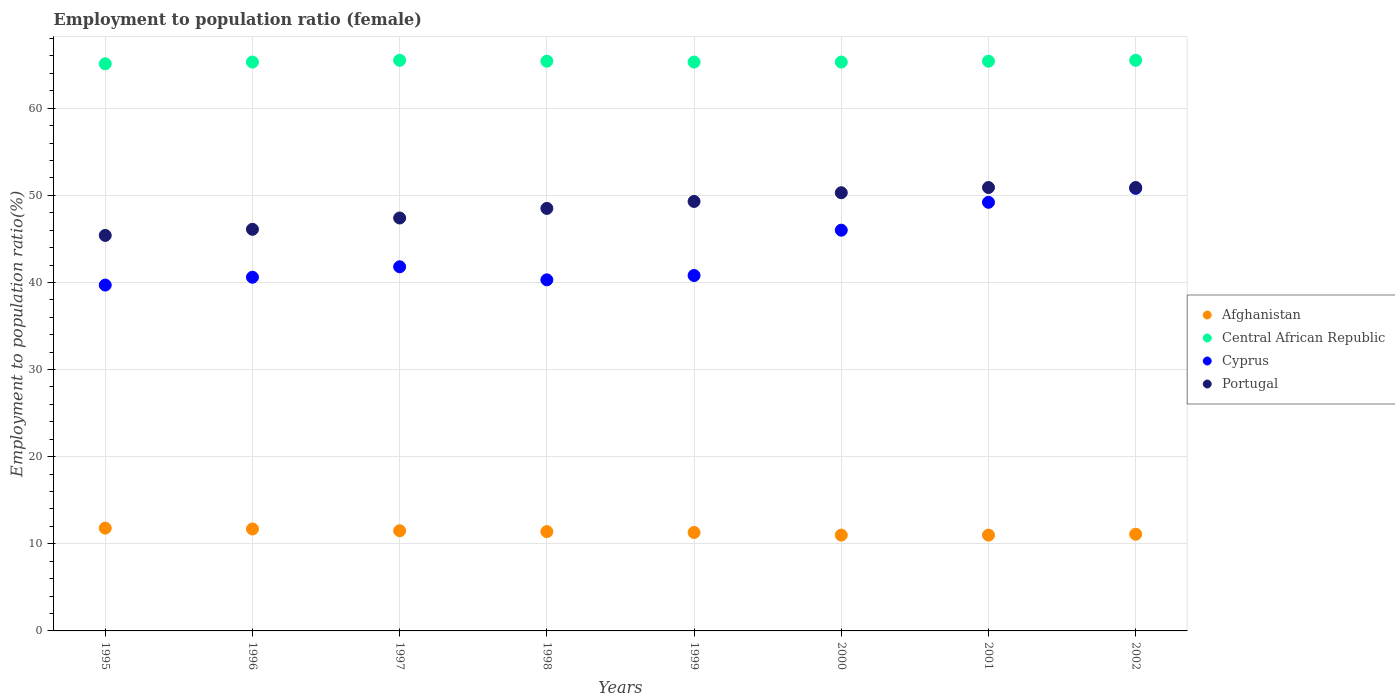Is the number of dotlines equal to the number of legend labels?
Make the answer very short. Yes. What is the employment to population ratio in Afghanistan in 1999?
Your answer should be compact. 11.3. Across all years, what is the maximum employment to population ratio in Cyprus?
Your answer should be very brief. 50.8. In which year was the employment to population ratio in Central African Republic maximum?
Offer a very short reply. 1997. In which year was the employment to population ratio in Cyprus minimum?
Ensure brevity in your answer.  1995. What is the total employment to population ratio in Portugal in the graph?
Ensure brevity in your answer.  388.8. What is the difference between the employment to population ratio in Afghanistan in 1997 and that in 2002?
Ensure brevity in your answer.  0.4. What is the difference between the employment to population ratio in Afghanistan in 1995 and the employment to population ratio in Portugal in 2001?
Ensure brevity in your answer.  -39.1. What is the average employment to population ratio in Portugal per year?
Your response must be concise. 48.6. In the year 1999, what is the difference between the employment to population ratio in Cyprus and employment to population ratio in Portugal?
Provide a succinct answer. -8.5. In how many years, is the employment to population ratio in Cyprus greater than 22 %?
Your answer should be very brief. 8. What is the ratio of the employment to population ratio in Portugal in 1998 to that in 2001?
Offer a very short reply. 0.95. Is the employment to population ratio in Portugal in 1998 less than that in 2001?
Your answer should be compact. Yes. What is the difference between the highest and the second highest employment to population ratio in Cyprus?
Ensure brevity in your answer.  1.6. What is the difference between the highest and the lowest employment to population ratio in Portugal?
Offer a terse response. 5.5. In how many years, is the employment to population ratio in Portugal greater than the average employment to population ratio in Portugal taken over all years?
Make the answer very short. 4. Is it the case that in every year, the sum of the employment to population ratio in Portugal and employment to population ratio in Afghanistan  is greater than the employment to population ratio in Central African Republic?
Make the answer very short. No. Is the employment to population ratio in Afghanistan strictly less than the employment to population ratio in Central African Republic over the years?
Make the answer very short. Yes. How many years are there in the graph?
Your answer should be very brief. 8. Are the values on the major ticks of Y-axis written in scientific E-notation?
Keep it short and to the point. No. How are the legend labels stacked?
Ensure brevity in your answer.  Vertical. What is the title of the graph?
Your answer should be very brief. Employment to population ratio (female). Does "St. Lucia" appear as one of the legend labels in the graph?
Offer a very short reply. No. What is the Employment to population ratio(%) of Afghanistan in 1995?
Keep it short and to the point. 11.8. What is the Employment to population ratio(%) in Central African Republic in 1995?
Give a very brief answer. 65.1. What is the Employment to population ratio(%) in Cyprus in 1995?
Give a very brief answer. 39.7. What is the Employment to population ratio(%) in Portugal in 1995?
Offer a terse response. 45.4. What is the Employment to population ratio(%) of Afghanistan in 1996?
Make the answer very short. 11.7. What is the Employment to population ratio(%) in Central African Republic in 1996?
Keep it short and to the point. 65.3. What is the Employment to population ratio(%) of Cyprus in 1996?
Your answer should be compact. 40.6. What is the Employment to population ratio(%) in Portugal in 1996?
Offer a very short reply. 46.1. What is the Employment to population ratio(%) in Afghanistan in 1997?
Your response must be concise. 11.5. What is the Employment to population ratio(%) in Central African Republic in 1997?
Your response must be concise. 65.5. What is the Employment to population ratio(%) in Cyprus in 1997?
Provide a short and direct response. 41.8. What is the Employment to population ratio(%) in Portugal in 1997?
Offer a very short reply. 47.4. What is the Employment to population ratio(%) in Afghanistan in 1998?
Your answer should be very brief. 11.4. What is the Employment to population ratio(%) of Central African Republic in 1998?
Your answer should be compact. 65.4. What is the Employment to population ratio(%) in Cyprus in 1998?
Offer a terse response. 40.3. What is the Employment to population ratio(%) of Portugal in 1998?
Provide a succinct answer. 48.5. What is the Employment to population ratio(%) of Afghanistan in 1999?
Keep it short and to the point. 11.3. What is the Employment to population ratio(%) of Central African Republic in 1999?
Your answer should be very brief. 65.3. What is the Employment to population ratio(%) of Cyprus in 1999?
Offer a terse response. 40.8. What is the Employment to population ratio(%) in Portugal in 1999?
Your response must be concise. 49.3. What is the Employment to population ratio(%) of Afghanistan in 2000?
Provide a succinct answer. 11. What is the Employment to population ratio(%) in Central African Republic in 2000?
Keep it short and to the point. 65.3. What is the Employment to population ratio(%) of Portugal in 2000?
Your response must be concise. 50.3. What is the Employment to population ratio(%) of Central African Republic in 2001?
Your answer should be compact. 65.4. What is the Employment to population ratio(%) in Cyprus in 2001?
Provide a short and direct response. 49.2. What is the Employment to population ratio(%) of Portugal in 2001?
Your answer should be compact. 50.9. What is the Employment to population ratio(%) of Afghanistan in 2002?
Provide a short and direct response. 11.1. What is the Employment to population ratio(%) of Central African Republic in 2002?
Your response must be concise. 65.5. What is the Employment to population ratio(%) of Cyprus in 2002?
Your answer should be very brief. 50.8. What is the Employment to population ratio(%) in Portugal in 2002?
Ensure brevity in your answer.  50.9. Across all years, what is the maximum Employment to population ratio(%) in Afghanistan?
Provide a short and direct response. 11.8. Across all years, what is the maximum Employment to population ratio(%) of Central African Republic?
Offer a very short reply. 65.5. Across all years, what is the maximum Employment to population ratio(%) in Cyprus?
Offer a very short reply. 50.8. Across all years, what is the maximum Employment to population ratio(%) of Portugal?
Your answer should be compact. 50.9. Across all years, what is the minimum Employment to population ratio(%) in Central African Republic?
Keep it short and to the point. 65.1. Across all years, what is the minimum Employment to population ratio(%) of Cyprus?
Give a very brief answer. 39.7. Across all years, what is the minimum Employment to population ratio(%) in Portugal?
Your answer should be compact. 45.4. What is the total Employment to population ratio(%) in Afghanistan in the graph?
Offer a terse response. 90.8. What is the total Employment to population ratio(%) in Central African Republic in the graph?
Ensure brevity in your answer.  522.8. What is the total Employment to population ratio(%) of Cyprus in the graph?
Your response must be concise. 349.2. What is the total Employment to population ratio(%) of Portugal in the graph?
Provide a short and direct response. 388.8. What is the difference between the Employment to population ratio(%) in Cyprus in 1995 and that in 1996?
Provide a short and direct response. -0.9. What is the difference between the Employment to population ratio(%) in Afghanistan in 1995 and that in 1997?
Provide a short and direct response. 0.3. What is the difference between the Employment to population ratio(%) of Cyprus in 1995 and that in 1997?
Offer a terse response. -2.1. What is the difference between the Employment to population ratio(%) of Afghanistan in 1995 and that in 1998?
Provide a succinct answer. 0.4. What is the difference between the Employment to population ratio(%) of Cyprus in 1995 and that in 1998?
Provide a succinct answer. -0.6. What is the difference between the Employment to population ratio(%) in Portugal in 1995 and that in 1998?
Offer a terse response. -3.1. What is the difference between the Employment to population ratio(%) in Cyprus in 1995 and that in 1999?
Keep it short and to the point. -1.1. What is the difference between the Employment to population ratio(%) in Cyprus in 1995 and that in 2000?
Make the answer very short. -6.3. What is the difference between the Employment to population ratio(%) of Portugal in 1995 and that in 2000?
Provide a short and direct response. -4.9. What is the difference between the Employment to population ratio(%) in Afghanistan in 1995 and that in 2001?
Provide a succinct answer. 0.8. What is the difference between the Employment to population ratio(%) of Portugal in 1995 and that in 2001?
Ensure brevity in your answer.  -5.5. What is the difference between the Employment to population ratio(%) in Afghanistan in 1995 and that in 2002?
Your answer should be very brief. 0.7. What is the difference between the Employment to population ratio(%) of Central African Republic in 1995 and that in 2002?
Ensure brevity in your answer.  -0.4. What is the difference between the Employment to population ratio(%) of Afghanistan in 1996 and that in 1998?
Offer a very short reply. 0.3. What is the difference between the Employment to population ratio(%) in Central African Republic in 1996 and that in 1998?
Ensure brevity in your answer.  -0.1. What is the difference between the Employment to population ratio(%) of Portugal in 1996 and that in 1998?
Give a very brief answer. -2.4. What is the difference between the Employment to population ratio(%) of Central African Republic in 1996 and that in 1999?
Make the answer very short. 0. What is the difference between the Employment to population ratio(%) in Afghanistan in 1996 and that in 2001?
Offer a very short reply. 0.7. What is the difference between the Employment to population ratio(%) of Cyprus in 1996 and that in 2001?
Offer a terse response. -8.6. What is the difference between the Employment to population ratio(%) of Portugal in 1996 and that in 2002?
Your answer should be very brief. -4.8. What is the difference between the Employment to population ratio(%) in Afghanistan in 1997 and that in 1998?
Your answer should be compact. 0.1. What is the difference between the Employment to population ratio(%) in Cyprus in 1997 and that in 1998?
Your response must be concise. 1.5. What is the difference between the Employment to population ratio(%) of Portugal in 1997 and that in 1998?
Your response must be concise. -1.1. What is the difference between the Employment to population ratio(%) of Afghanistan in 1997 and that in 1999?
Your answer should be compact. 0.2. What is the difference between the Employment to population ratio(%) in Afghanistan in 1997 and that in 2000?
Your response must be concise. 0.5. What is the difference between the Employment to population ratio(%) of Central African Republic in 1997 and that in 2000?
Offer a very short reply. 0.2. What is the difference between the Employment to population ratio(%) of Cyprus in 1997 and that in 2000?
Keep it short and to the point. -4.2. What is the difference between the Employment to population ratio(%) in Portugal in 1997 and that in 2001?
Make the answer very short. -3.5. What is the difference between the Employment to population ratio(%) of Cyprus in 1997 and that in 2002?
Your answer should be compact. -9. What is the difference between the Employment to population ratio(%) in Central African Republic in 1998 and that in 1999?
Offer a very short reply. 0.1. What is the difference between the Employment to population ratio(%) in Cyprus in 1998 and that in 1999?
Your answer should be very brief. -0.5. What is the difference between the Employment to population ratio(%) of Portugal in 1998 and that in 1999?
Ensure brevity in your answer.  -0.8. What is the difference between the Employment to population ratio(%) in Afghanistan in 1998 and that in 2000?
Make the answer very short. 0.4. What is the difference between the Employment to population ratio(%) in Central African Republic in 1998 and that in 2000?
Your answer should be compact. 0.1. What is the difference between the Employment to population ratio(%) in Portugal in 1998 and that in 2000?
Keep it short and to the point. -1.8. What is the difference between the Employment to population ratio(%) of Afghanistan in 1998 and that in 2001?
Provide a short and direct response. 0.4. What is the difference between the Employment to population ratio(%) of Central African Republic in 1998 and that in 2001?
Your answer should be very brief. 0. What is the difference between the Employment to population ratio(%) in Cyprus in 1998 and that in 2001?
Provide a short and direct response. -8.9. What is the difference between the Employment to population ratio(%) in Portugal in 1998 and that in 2001?
Offer a terse response. -2.4. What is the difference between the Employment to population ratio(%) in Afghanistan in 1998 and that in 2002?
Provide a short and direct response. 0.3. What is the difference between the Employment to population ratio(%) of Central African Republic in 1998 and that in 2002?
Provide a succinct answer. -0.1. What is the difference between the Employment to population ratio(%) in Cyprus in 1999 and that in 2000?
Keep it short and to the point. -5.2. What is the difference between the Employment to population ratio(%) of Portugal in 1999 and that in 2000?
Ensure brevity in your answer.  -1. What is the difference between the Employment to population ratio(%) of Cyprus in 1999 and that in 2001?
Your answer should be compact. -8.4. What is the difference between the Employment to population ratio(%) in Portugal in 1999 and that in 2001?
Provide a succinct answer. -1.6. What is the difference between the Employment to population ratio(%) of Central African Republic in 1999 and that in 2002?
Ensure brevity in your answer.  -0.2. What is the difference between the Employment to population ratio(%) of Cyprus in 1999 and that in 2002?
Your response must be concise. -10. What is the difference between the Employment to population ratio(%) in Central African Republic in 2000 and that in 2001?
Provide a succinct answer. -0.1. What is the difference between the Employment to population ratio(%) of Portugal in 2000 and that in 2001?
Provide a short and direct response. -0.6. What is the difference between the Employment to population ratio(%) in Afghanistan in 2001 and that in 2002?
Ensure brevity in your answer.  -0.1. What is the difference between the Employment to population ratio(%) of Portugal in 2001 and that in 2002?
Make the answer very short. 0. What is the difference between the Employment to population ratio(%) in Afghanistan in 1995 and the Employment to population ratio(%) in Central African Republic in 1996?
Offer a very short reply. -53.5. What is the difference between the Employment to population ratio(%) in Afghanistan in 1995 and the Employment to population ratio(%) in Cyprus in 1996?
Make the answer very short. -28.8. What is the difference between the Employment to population ratio(%) of Afghanistan in 1995 and the Employment to population ratio(%) of Portugal in 1996?
Offer a very short reply. -34.3. What is the difference between the Employment to population ratio(%) in Central African Republic in 1995 and the Employment to population ratio(%) in Portugal in 1996?
Provide a succinct answer. 19. What is the difference between the Employment to population ratio(%) of Afghanistan in 1995 and the Employment to population ratio(%) of Central African Republic in 1997?
Make the answer very short. -53.7. What is the difference between the Employment to population ratio(%) of Afghanistan in 1995 and the Employment to population ratio(%) of Portugal in 1997?
Keep it short and to the point. -35.6. What is the difference between the Employment to population ratio(%) in Central African Republic in 1995 and the Employment to population ratio(%) in Cyprus in 1997?
Offer a terse response. 23.3. What is the difference between the Employment to population ratio(%) of Central African Republic in 1995 and the Employment to population ratio(%) of Portugal in 1997?
Provide a succinct answer. 17.7. What is the difference between the Employment to population ratio(%) in Afghanistan in 1995 and the Employment to population ratio(%) in Central African Republic in 1998?
Offer a very short reply. -53.6. What is the difference between the Employment to population ratio(%) in Afghanistan in 1995 and the Employment to population ratio(%) in Cyprus in 1998?
Ensure brevity in your answer.  -28.5. What is the difference between the Employment to population ratio(%) of Afghanistan in 1995 and the Employment to population ratio(%) of Portugal in 1998?
Keep it short and to the point. -36.7. What is the difference between the Employment to population ratio(%) of Central African Republic in 1995 and the Employment to population ratio(%) of Cyprus in 1998?
Your answer should be compact. 24.8. What is the difference between the Employment to population ratio(%) of Central African Republic in 1995 and the Employment to population ratio(%) of Portugal in 1998?
Your answer should be very brief. 16.6. What is the difference between the Employment to population ratio(%) of Afghanistan in 1995 and the Employment to population ratio(%) of Central African Republic in 1999?
Your answer should be very brief. -53.5. What is the difference between the Employment to population ratio(%) of Afghanistan in 1995 and the Employment to population ratio(%) of Cyprus in 1999?
Provide a short and direct response. -29. What is the difference between the Employment to population ratio(%) of Afghanistan in 1995 and the Employment to population ratio(%) of Portugal in 1999?
Offer a terse response. -37.5. What is the difference between the Employment to population ratio(%) of Central African Republic in 1995 and the Employment to population ratio(%) of Cyprus in 1999?
Offer a terse response. 24.3. What is the difference between the Employment to population ratio(%) in Cyprus in 1995 and the Employment to population ratio(%) in Portugal in 1999?
Keep it short and to the point. -9.6. What is the difference between the Employment to population ratio(%) of Afghanistan in 1995 and the Employment to population ratio(%) of Central African Republic in 2000?
Provide a succinct answer. -53.5. What is the difference between the Employment to population ratio(%) of Afghanistan in 1995 and the Employment to population ratio(%) of Cyprus in 2000?
Make the answer very short. -34.2. What is the difference between the Employment to population ratio(%) in Afghanistan in 1995 and the Employment to population ratio(%) in Portugal in 2000?
Offer a very short reply. -38.5. What is the difference between the Employment to population ratio(%) in Cyprus in 1995 and the Employment to population ratio(%) in Portugal in 2000?
Offer a very short reply. -10.6. What is the difference between the Employment to population ratio(%) of Afghanistan in 1995 and the Employment to population ratio(%) of Central African Republic in 2001?
Provide a short and direct response. -53.6. What is the difference between the Employment to population ratio(%) of Afghanistan in 1995 and the Employment to population ratio(%) of Cyprus in 2001?
Offer a very short reply. -37.4. What is the difference between the Employment to population ratio(%) in Afghanistan in 1995 and the Employment to population ratio(%) in Portugal in 2001?
Your response must be concise. -39.1. What is the difference between the Employment to population ratio(%) in Afghanistan in 1995 and the Employment to population ratio(%) in Central African Republic in 2002?
Offer a terse response. -53.7. What is the difference between the Employment to population ratio(%) of Afghanistan in 1995 and the Employment to population ratio(%) of Cyprus in 2002?
Your answer should be very brief. -39. What is the difference between the Employment to population ratio(%) in Afghanistan in 1995 and the Employment to population ratio(%) in Portugal in 2002?
Keep it short and to the point. -39.1. What is the difference between the Employment to population ratio(%) in Central African Republic in 1995 and the Employment to population ratio(%) in Cyprus in 2002?
Your answer should be compact. 14.3. What is the difference between the Employment to population ratio(%) of Central African Republic in 1995 and the Employment to population ratio(%) of Portugal in 2002?
Provide a succinct answer. 14.2. What is the difference between the Employment to population ratio(%) in Cyprus in 1995 and the Employment to population ratio(%) in Portugal in 2002?
Give a very brief answer. -11.2. What is the difference between the Employment to population ratio(%) in Afghanistan in 1996 and the Employment to population ratio(%) in Central African Republic in 1997?
Make the answer very short. -53.8. What is the difference between the Employment to population ratio(%) of Afghanistan in 1996 and the Employment to population ratio(%) of Cyprus in 1997?
Your response must be concise. -30.1. What is the difference between the Employment to population ratio(%) of Afghanistan in 1996 and the Employment to population ratio(%) of Portugal in 1997?
Your answer should be compact. -35.7. What is the difference between the Employment to population ratio(%) in Central African Republic in 1996 and the Employment to population ratio(%) in Cyprus in 1997?
Keep it short and to the point. 23.5. What is the difference between the Employment to population ratio(%) of Cyprus in 1996 and the Employment to population ratio(%) of Portugal in 1997?
Offer a terse response. -6.8. What is the difference between the Employment to population ratio(%) in Afghanistan in 1996 and the Employment to population ratio(%) in Central African Republic in 1998?
Provide a short and direct response. -53.7. What is the difference between the Employment to population ratio(%) of Afghanistan in 1996 and the Employment to population ratio(%) of Cyprus in 1998?
Give a very brief answer. -28.6. What is the difference between the Employment to population ratio(%) of Afghanistan in 1996 and the Employment to population ratio(%) of Portugal in 1998?
Make the answer very short. -36.8. What is the difference between the Employment to population ratio(%) in Afghanistan in 1996 and the Employment to population ratio(%) in Central African Republic in 1999?
Give a very brief answer. -53.6. What is the difference between the Employment to population ratio(%) in Afghanistan in 1996 and the Employment to population ratio(%) in Cyprus in 1999?
Offer a very short reply. -29.1. What is the difference between the Employment to population ratio(%) of Afghanistan in 1996 and the Employment to population ratio(%) of Portugal in 1999?
Offer a terse response. -37.6. What is the difference between the Employment to population ratio(%) of Afghanistan in 1996 and the Employment to population ratio(%) of Central African Republic in 2000?
Make the answer very short. -53.6. What is the difference between the Employment to population ratio(%) of Afghanistan in 1996 and the Employment to population ratio(%) of Cyprus in 2000?
Keep it short and to the point. -34.3. What is the difference between the Employment to population ratio(%) in Afghanistan in 1996 and the Employment to population ratio(%) in Portugal in 2000?
Keep it short and to the point. -38.6. What is the difference between the Employment to population ratio(%) of Central African Republic in 1996 and the Employment to population ratio(%) of Cyprus in 2000?
Offer a very short reply. 19.3. What is the difference between the Employment to population ratio(%) in Central African Republic in 1996 and the Employment to population ratio(%) in Portugal in 2000?
Your response must be concise. 15. What is the difference between the Employment to population ratio(%) in Cyprus in 1996 and the Employment to population ratio(%) in Portugal in 2000?
Provide a short and direct response. -9.7. What is the difference between the Employment to population ratio(%) of Afghanistan in 1996 and the Employment to population ratio(%) of Central African Republic in 2001?
Ensure brevity in your answer.  -53.7. What is the difference between the Employment to population ratio(%) in Afghanistan in 1996 and the Employment to population ratio(%) in Cyprus in 2001?
Give a very brief answer. -37.5. What is the difference between the Employment to population ratio(%) of Afghanistan in 1996 and the Employment to population ratio(%) of Portugal in 2001?
Ensure brevity in your answer.  -39.2. What is the difference between the Employment to population ratio(%) in Cyprus in 1996 and the Employment to population ratio(%) in Portugal in 2001?
Offer a terse response. -10.3. What is the difference between the Employment to population ratio(%) of Afghanistan in 1996 and the Employment to population ratio(%) of Central African Republic in 2002?
Give a very brief answer. -53.8. What is the difference between the Employment to population ratio(%) of Afghanistan in 1996 and the Employment to population ratio(%) of Cyprus in 2002?
Ensure brevity in your answer.  -39.1. What is the difference between the Employment to population ratio(%) in Afghanistan in 1996 and the Employment to population ratio(%) in Portugal in 2002?
Make the answer very short. -39.2. What is the difference between the Employment to population ratio(%) in Cyprus in 1996 and the Employment to population ratio(%) in Portugal in 2002?
Ensure brevity in your answer.  -10.3. What is the difference between the Employment to population ratio(%) of Afghanistan in 1997 and the Employment to population ratio(%) of Central African Republic in 1998?
Ensure brevity in your answer.  -53.9. What is the difference between the Employment to population ratio(%) of Afghanistan in 1997 and the Employment to population ratio(%) of Cyprus in 1998?
Give a very brief answer. -28.8. What is the difference between the Employment to population ratio(%) of Afghanistan in 1997 and the Employment to population ratio(%) of Portugal in 1998?
Ensure brevity in your answer.  -37. What is the difference between the Employment to population ratio(%) of Central African Republic in 1997 and the Employment to population ratio(%) of Cyprus in 1998?
Offer a terse response. 25.2. What is the difference between the Employment to population ratio(%) in Cyprus in 1997 and the Employment to population ratio(%) in Portugal in 1998?
Your response must be concise. -6.7. What is the difference between the Employment to population ratio(%) in Afghanistan in 1997 and the Employment to population ratio(%) in Central African Republic in 1999?
Provide a short and direct response. -53.8. What is the difference between the Employment to population ratio(%) of Afghanistan in 1997 and the Employment to population ratio(%) of Cyprus in 1999?
Make the answer very short. -29.3. What is the difference between the Employment to population ratio(%) in Afghanistan in 1997 and the Employment to population ratio(%) in Portugal in 1999?
Your answer should be very brief. -37.8. What is the difference between the Employment to population ratio(%) in Central African Republic in 1997 and the Employment to population ratio(%) in Cyprus in 1999?
Provide a short and direct response. 24.7. What is the difference between the Employment to population ratio(%) of Cyprus in 1997 and the Employment to population ratio(%) of Portugal in 1999?
Offer a very short reply. -7.5. What is the difference between the Employment to population ratio(%) of Afghanistan in 1997 and the Employment to population ratio(%) of Central African Republic in 2000?
Provide a short and direct response. -53.8. What is the difference between the Employment to population ratio(%) of Afghanistan in 1997 and the Employment to population ratio(%) of Cyprus in 2000?
Your answer should be very brief. -34.5. What is the difference between the Employment to population ratio(%) of Afghanistan in 1997 and the Employment to population ratio(%) of Portugal in 2000?
Keep it short and to the point. -38.8. What is the difference between the Employment to population ratio(%) of Afghanistan in 1997 and the Employment to population ratio(%) of Central African Republic in 2001?
Your answer should be very brief. -53.9. What is the difference between the Employment to population ratio(%) in Afghanistan in 1997 and the Employment to population ratio(%) in Cyprus in 2001?
Offer a terse response. -37.7. What is the difference between the Employment to population ratio(%) in Afghanistan in 1997 and the Employment to population ratio(%) in Portugal in 2001?
Provide a short and direct response. -39.4. What is the difference between the Employment to population ratio(%) in Central African Republic in 1997 and the Employment to population ratio(%) in Portugal in 2001?
Offer a terse response. 14.6. What is the difference between the Employment to population ratio(%) of Cyprus in 1997 and the Employment to population ratio(%) of Portugal in 2001?
Make the answer very short. -9.1. What is the difference between the Employment to population ratio(%) in Afghanistan in 1997 and the Employment to population ratio(%) in Central African Republic in 2002?
Make the answer very short. -54. What is the difference between the Employment to population ratio(%) in Afghanistan in 1997 and the Employment to population ratio(%) in Cyprus in 2002?
Provide a succinct answer. -39.3. What is the difference between the Employment to population ratio(%) of Afghanistan in 1997 and the Employment to population ratio(%) of Portugal in 2002?
Your response must be concise. -39.4. What is the difference between the Employment to population ratio(%) of Central African Republic in 1997 and the Employment to population ratio(%) of Cyprus in 2002?
Your answer should be very brief. 14.7. What is the difference between the Employment to population ratio(%) in Central African Republic in 1997 and the Employment to population ratio(%) in Portugal in 2002?
Offer a very short reply. 14.6. What is the difference between the Employment to population ratio(%) of Afghanistan in 1998 and the Employment to population ratio(%) of Central African Republic in 1999?
Give a very brief answer. -53.9. What is the difference between the Employment to population ratio(%) in Afghanistan in 1998 and the Employment to population ratio(%) in Cyprus in 1999?
Give a very brief answer. -29.4. What is the difference between the Employment to population ratio(%) of Afghanistan in 1998 and the Employment to population ratio(%) of Portugal in 1999?
Provide a succinct answer. -37.9. What is the difference between the Employment to population ratio(%) of Central African Republic in 1998 and the Employment to population ratio(%) of Cyprus in 1999?
Give a very brief answer. 24.6. What is the difference between the Employment to population ratio(%) of Cyprus in 1998 and the Employment to population ratio(%) of Portugal in 1999?
Ensure brevity in your answer.  -9. What is the difference between the Employment to population ratio(%) in Afghanistan in 1998 and the Employment to population ratio(%) in Central African Republic in 2000?
Your answer should be compact. -53.9. What is the difference between the Employment to population ratio(%) in Afghanistan in 1998 and the Employment to population ratio(%) in Cyprus in 2000?
Your answer should be very brief. -34.6. What is the difference between the Employment to population ratio(%) in Afghanistan in 1998 and the Employment to population ratio(%) in Portugal in 2000?
Offer a terse response. -38.9. What is the difference between the Employment to population ratio(%) in Central African Republic in 1998 and the Employment to population ratio(%) in Cyprus in 2000?
Your answer should be very brief. 19.4. What is the difference between the Employment to population ratio(%) of Afghanistan in 1998 and the Employment to population ratio(%) of Central African Republic in 2001?
Offer a terse response. -54. What is the difference between the Employment to population ratio(%) in Afghanistan in 1998 and the Employment to population ratio(%) in Cyprus in 2001?
Your response must be concise. -37.8. What is the difference between the Employment to population ratio(%) in Afghanistan in 1998 and the Employment to population ratio(%) in Portugal in 2001?
Your answer should be compact. -39.5. What is the difference between the Employment to population ratio(%) in Central African Republic in 1998 and the Employment to population ratio(%) in Cyprus in 2001?
Offer a very short reply. 16.2. What is the difference between the Employment to population ratio(%) in Central African Republic in 1998 and the Employment to population ratio(%) in Portugal in 2001?
Your response must be concise. 14.5. What is the difference between the Employment to population ratio(%) in Cyprus in 1998 and the Employment to population ratio(%) in Portugal in 2001?
Offer a terse response. -10.6. What is the difference between the Employment to population ratio(%) of Afghanistan in 1998 and the Employment to population ratio(%) of Central African Republic in 2002?
Offer a terse response. -54.1. What is the difference between the Employment to population ratio(%) in Afghanistan in 1998 and the Employment to population ratio(%) in Cyprus in 2002?
Make the answer very short. -39.4. What is the difference between the Employment to population ratio(%) in Afghanistan in 1998 and the Employment to population ratio(%) in Portugal in 2002?
Your answer should be compact. -39.5. What is the difference between the Employment to population ratio(%) in Central African Republic in 1998 and the Employment to population ratio(%) in Cyprus in 2002?
Give a very brief answer. 14.6. What is the difference between the Employment to population ratio(%) of Cyprus in 1998 and the Employment to population ratio(%) of Portugal in 2002?
Provide a succinct answer. -10.6. What is the difference between the Employment to population ratio(%) of Afghanistan in 1999 and the Employment to population ratio(%) of Central African Republic in 2000?
Your response must be concise. -54. What is the difference between the Employment to population ratio(%) of Afghanistan in 1999 and the Employment to population ratio(%) of Cyprus in 2000?
Offer a very short reply. -34.7. What is the difference between the Employment to population ratio(%) in Afghanistan in 1999 and the Employment to population ratio(%) in Portugal in 2000?
Your response must be concise. -39. What is the difference between the Employment to population ratio(%) of Central African Republic in 1999 and the Employment to population ratio(%) of Cyprus in 2000?
Your answer should be very brief. 19.3. What is the difference between the Employment to population ratio(%) in Cyprus in 1999 and the Employment to population ratio(%) in Portugal in 2000?
Give a very brief answer. -9.5. What is the difference between the Employment to population ratio(%) in Afghanistan in 1999 and the Employment to population ratio(%) in Central African Republic in 2001?
Ensure brevity in your answer.  -54.1. What is the difference between the Employment to population ratio(%) of Afghanistan in 1999 and the Employment to population ratio(%) of Cyprus in 2001?
Offer a very short reply. -37.9. What is the difference between the Employment to population ratio(%) in Afghanistan in 1999 and the Employment to population ratio(%) in Portugal in 2001?
Give a very brief answer. -39.6. What is the difference between the Employment to population ratio(%) in Central African Republic in 1999 and the Employment to population ratio(%) in Cyprus in 2001?
Ensure brevity in your answer.  16.1. What is the difference between the Employment to population ratio(%) of Afghanistan in 1999 and the Employment to population ratio(%) of Central African Republic in 2002?
Keep it short and to the point. -54.2. What is the difference between the Employment to population ratio(%) in Afghanistan in 1999 and the Employment to population ratio(%) in Cyprus in 2002?
Offer a very short reply. -39.5. What is the difference between the Employment to population ratio(%) of Afghanistan in 1999 and the Employment to population ratio(%) of Portugal in 2002?
Offer a very short reply. -39.6. What is the difference between the Employment to population ratio(%) in Cyprus in 1999 and the Employment to population ratio(%) in Portugal in 2002?
Ensure brevity in your answer.  -10.1. What is the difference between the Employment to population ratio(%) in Afghanistan in 2000 and the Employment to population ratio(%) in Central African Republic in 2001?
Provide a succinct answer. -54.4. What is the difference between the Employment to population ratio(%) of Afghanistan in 2000 and the Employment to population ratio(%) of Cyprus in 2001?
Offer a very short reply. -38.2. What is the difference between the Employment to population ratio(%) in Afghanistan in 2000 and the Employment to population ratio(%) in Portugal in 2001?
Make the answer very short. -39.9. What is the difference between the Employment to population ratio(%) of Afghanistan in 2000 and the Employment to population ratio(%) of Central African Republic in 2002?
Your response must be concise. -54.5. What is the difference between the Employment to population ratio(%) in Afghanistan in 2000 and the Employment to population ratio(%) in Cyprus in 2002?
Give a very brief answer. -39.8. What is the difference between the Employment to population ratio(%) of Afghanistan in 2000 and the Employment to population ratio(%) of Portugal in 2002?
Give a very brief answer. -39.9. What is the difference between the Employment to population ratio(%) of Afghanistan in 2001 and the Employment to population ratio(%) of Central African Republic in 2002?
Keep it short and to the point. -54.5. What is the difference between the Employment to population ratio(%) in Afghanistan in 2001 and the Employment to population ratio(%) in Cyprus in 2002?
Offer a terse response. -39.8. What is the difference between the Employment to population ratio(%) of Afghanistan in 2001 and the Employment to population ratio(%) of Portugal in 2002?
Keep it short and to the point. -39.9. What is the average Employment to population ratio(%) in Afghanistan per year?
Provide a succinct answer. 11.35. What is the average Employment to population ratio(%) of Central African Republic per year?
Your answer should be compact. 65.35. What is the average Employment to population ratio(%) of Cyprus per year?
Provide a short and direct response. 43.65. What is the average Employment to population ratio(%) of Portugal per year?
Keep it short and to the point. 48.6. In the year 1995, what is the difference between the Employment to population ratio(%) of Afghanistan and Employment to population ratio(%) of Central African Republic?
Your response must be concise. -53.3. In the year 1995, what is the difference between the Employment to population ratio(%) in Afghanistan and Employment to population ratio(%) in Cyprus?
Your answer should be compact. -27.9. In the year 1995, what is the difference between the Employment to population ratio(%) of Afghanistan and Employment to population ratio(%) of Portugal?
Your answer should be compact. -33.6. In the year 1995, what is the difference between the Employment to population ratio(%) of Central African Republic and Employment to population ratio(%) of Cyprus?
Provide a succinct answer. 25.4. In the year 1995, what is the difference between the Employment to population ratio(%) in Central African Republic and Employment to population ratio(%) in Portugal?
Give a very brief answer. 19.7. In the year 1996, what is the difference between the Employment to population ratio(%) of Afghanistan and Employment to population ratio(%) of Central African Republic?
Provide a succinct answer. -53.6. In the year 1996, what is the difference between the Employment to population ratio(%) of Afghanistan and Employment to population ratio(%) of Cyprus?
Your response must be concise. -28.9. In the year 1996, what is the difference between the Employment to population ratio(%) of Afghanistan and Employment to population ratio(%) of Portugal?
Provide a succinct answer. -34.4. In the year 1996, what is the difference between the Employment to population ratio(%) in Central African Republic and Employment to population ratio(%) in Cyprus?
Make the answer very short. 24.7. In the year 1996, what is the difference between the Employment to population ratio(%) of Central African Republic and Employment to population ratio(%) of Portugal?
Give a very brief answer. 19.2. In the year 1997, what is the difference between the Employment to population ratio(%) of Afghanistan and Employment to population ratio(%) of Central African Republic?
Provide a succinct answer. -54. In the year 1997, what is the difference between the Employment to population ratio(%) in Afghanistan and Employment to population ratio(%) in Cyprus?
Offer a very short reply. -30.3. In the year 1997, what is the difference between the Employment to population ratio(%) in Afghanistan and Employment to population ratio(%) in Portugal?
Give a very brief answer. -35.9. In the year 1997, what is the difference between the Employment to population ratio(%) of Central African Republic and Employment to population ratio(%) of Cyprus?
Your answer should be compact. 23.7. In the year 1997, what is the difference between the Employment to population ratio(%) of Central African Republic and Employment to population ratio(%) of Portugal?
Ensure brevity in your answer.  18.1. In the year 1998, what is the difference between the Employment to population ratio(%) of Afghanistan and Employment to population ratio(%) of Central African Republic?
Your answer should be very brief. -54. In the year 1998, what is the difference between the Employment to population ratio(%) in Afghanistan and Employment to population ratio(%) in Cyprus?
Offer a very short reply. -28.9. In the year 1998, what is the difference between the Employment to population ratio(%) in Afghanistan and Employment to population ratio(%) in Portugal?
Ensure brevity in your answer.  -37.1. In the year 1998, what is the difference between the Employment to population ratio(%) of Central African Republic and Employment to population ratio(%) of Cyprus?
Your response must be concise. 25.1. In the year 1998, what is the difference between the Employment to population ratio(%) in Cyprus and Employment to population ratio(%) in Portugal?
Your answer should be compact. -8.2. In the year 1999, what is the difference between the Employment to population ratio(%) of Afghanistan and Employment to population ratio(%) of Central African Republic?
Your answer should be compact. -54. In the year 1999, what is the difference between the Employment to population ratio(%) of Afghanistan and Employment to population ratio(%) of Cyprus?
Your answer should be very brief. -29.5. In the year 1999, what is the difference between the Employment to population ratio(%) in Afghanistan and Employment to population ratio(%) in Portugal?
Offer a very short reply. -38. In the year 1999, what is the difference between the Employment to population ratio(%) of Cyprus and Employment to population ratio(%) of Portugal?
Provide a succinct answer. -8.5. In the year 2000, what is the difference between the Employment to population ratio(%) in Afghanistan and Employment to population ratio(%) in Central African Republic?
Offer a very short reply. -54.3. In the year 2000, what is the difference between the Employment to population ratio(%) of Afghanistan and Employment to population ratio(%) of Cyprus?
Ensure brevity in your answer.  -35. In the year 2000, what is the difference between the Employment to population ratio(%) in Afghanistan and Employment to population ratio(%) in Portugal?
Offer a terse response. -39.3. In the year 2000, what is the difference between the Employment to population ratio(%) of Central African Republic and Employment to population ratio(%) of Cyprus?
Provide a short and direct response. 19.3. In the year 2000, what is the difference between the Employment to population ratio(%) of Central African Republic and Employment to population ratio(%) of Portugal?
Your answer should be very brief. 15. In the year 2000, what is the difference between the Employment to population ratio(%) of Cyprus and Employment to population ratio(%) of Portugal?
Your response must be concise. -4.3. In the year 2001, what is the difference between the Employment to population ratio(%) in Afghanistan and Employment to population ratio(%) in Central African Republic?
Ensure brevity in your answer.  -54.4. In the year 2001, what is the difference between the Employment to population ratio(%) in Afghanistan and Employment to population ratio(%) in Cyprus?
Offer a very short reply. -38.2. In the year 2001, what is the difference between the Employment to population ratio(%) of Afghanistan and Employment to population ratio(%) of Portugal?
Keep it short and to the point. -39.9. In the year 2001, what is the difference between the Employment to population ratio(%) in Cyprus and Employment to population ratio(%) in Portugal?
Provide a short and direct response. -1.7. In the year 2002, what is the difference between the Employment to population ratio(%) of Afghanistan and Employment to population ratio(%) of Central African Republic?
Keep it short and to the point. -54.4. In the year 2002, what is the difference between the Employment to population ratio(%) in Afghanistan and Employment to population ratio(%) in Cyprus?
Your response must be concise. -39.7. In the year 2002, what is the difference between the Employment to population ratio(%) in Afghanistan and Employment to population ratio(%) in Portugal?
Provide a succinct answer. -39.8. What is the ratio of the Employment to population ratio(%) of Afghanistan in 1995 to that in 1996?
Make the answer very short. 1.01. What is the ratio of the Employment to population ratio(%) in Central African Republic in 1995 to that in 1996?
Your answer should be compact. 1. What is the ratio of the Employment to population ratio(%) in Cyprus in 1995 to that in 1996?
Give a very brief answer. 0.98. What is the ratio of the Employment to population ratio(%) of Portugal in 1995 to that in 1996?
Ensure brevity in your answer.  0.98. What is the ratio of the Employment to population ratio(%) in Afghanistan in 1995 to that in 1997?
Your response must be concise. 1.03. What is the ratio of the Employment to population ratio(%) in Cyprus in 1995 to that in 1997?
Ensure brevity in your answer.  0.95. What is the ratio of the Employment to population ratio(%) of Portugal in 1995 to that in 1997?
Ensure brevity in your answer.  0.96. What is the ratio of the Employment to population ratio(%) of Afghanistan in 1995 to that in 1998?
Give a very brief answer. 1.04. What is the ratio of the Employment to population ratio(%) of Central African Republic in 1995 to that in 1998?
Ensure brevity in your answer.  1. What is the ratio of the Employment to population ratio(%) of Cyprus in 1995 to that in 1998?
Ensure brevity in your answer.  0.99. What is the ratio of the Employment to population ratio(%) in Portugal in 1995 to that in 1998?
Your answer should be very brief. 0.94. What is the ratio of the Employment to population ratio(%) in Afghanistan in 1995 to that in 1999?
Your answer should be compact. 1.04. What is the ratio of the Employment to population ratio(%) in Central African Republic in 1995 to that in 1999?
Keep it short and to the point. 1. What is the ratio of the Employment to population ratio(%) in Cyprus in 1995 to that in 1999?
Your answer should be very brief. 0.97. What is the ratio of the Employment to population ratio(%) of Portugal in 1995 to that in 1999?
Provide a short and direct response. 0.92. What is the ratio of the Employment to population ratio(%) of Afghanistan in 1995 to that in 2000?
Ensure brevity in your answer.  1.07. What is the ratio of the Employment to population ratio(%) in Central African Republic in 1995 to that in 2000?
Make the answer very short. 1. What is the ratio of the Employment to population ratio(%) in Cyprus in 1995 to that in 2000?
Provide a short and direct response. 0.86. What is the ratio of the Employment to population ratio(%) of Portugal in 1995 to that in 2000?
Provide a short and direct response. 0.9. What is the ratio of the Employment to population ratio(%) of Afghanistan in 1995 to that in 2001?
Offer a very short reply. 1.07. What is the ratio of the Employment to population ratio(%) of Cyprus in 1995 to that in 2001?
Ensure brevity in your answer.  0.81. What is the ratio of the Employment to population ratio(%) of Portugal in 1995 to that in 2001?
Your answer should be compact. 0.89. What is the ratio of the Employment to population ratio(%) in Afghanistan in 1995 to that in 2002?
Ensure brevity in your answer.  1.06. What is the ratio of the Employment to population ratio(%) in Central African Republic in 1995 to that in 2002?
Keep it short and to the point. 0.99. What is the ratio of the Employment to population ratio(%) of Cyprus in 1995 to that in 2002?
Provide a short and direct response. 0.78. What is the ratio of the Employment to population ratio(%) in Portugal in 1995 to that in 2002?
Your answer should be very brief. 0.89. What is the ratio of the Employment to population ratio(%) in Afghanistan in 1996 to that in 1997?
Offer a terse response. 1.02. What is the ratio of the Employment to population ratio(%) in Central African Republic in 1996 to that in 1997?
Your answer should be very brief. 1. What is the ratio of the Employment to population ratio(%) in Cyprus in 1996 to that in 1997?
Keep it short and to the point. 0.97. What is the ratio of the Employment to population ratio(%) in Portugal in 1996 to that in 1997?
Provide a short and direct response. 0.97. What is the ratio of the Employment to population ratio(%) of Afghanistan in 1996 to that in 1998?
Your answer should be compact. 1.03. What is the ratio of the Employment to population ratio(%) of Central African Republic in 1996 to that in 1998?
Ensure brevity in your answer.  1. What is the ratio of the Employment to population ratio(%) of Cyprus in 1996 to that in 1998?
Offer a very short reply. 1.01. What is the ratio of the Employment to population ratio(%) of Portugal in 1996 to that in 1998?
Keep it short and to the point. 0.95. What is the ratio of the Employment to population ratio(%) in Afghanistan in 1996 to that in 1999?
Keep it short and to the point. 1.04. What is the ratio of the Employment to population ratio(%) of Central African Republic in 1996 to that in 1999?
Your response must be concise. 1. What is the ratio of the Employment to population ratio(%) of Cyprus in 1996 to that in 1999?
Make the answer very short. 1. What is the ratio of the Employment to population ratio(%) in Portugal in 1996 to that in 1999?
Provide a succinct answer. 0.94. What is the ratio of the Employment to population ratio(%) in Afghanistan in 1996 to that in 2000?
Your answer should be compact. 1.06. What is the ratio of the Employment to population ratio(%) in Cyprus in 1996 to that in 2000?
Your answer should be very brief. 0.88. What is the ratio of the Employment to population ratio(%) of Portugal in 1996 to that in 2000?
Offer a very short reply. 0.92. What is the ratio of the Employment to population ratio(%) in Afghanistan in 1996 to that in 2001?
Offer a terse response. 1.06. What is the ratio of the Employment to population ratio(%) of Cyprus in 1996 to that in 2001?
Keep it short and to the point. 0.83. What is the ratio of the Employment to population ratio(%) of Portugal in 1996 to that in 2001?
Your answer should be compact. 0.91. What is the ratio of the Employment to population ratio(%) of Afghanistan in 1996 to that in 2002?
Provide a succinct answer. 1.05. What is the ratio of the Employment to population ratio(%) of Cyprus in 1996 to that in 2002?
Offer a terse response. 0.8. What is the ratio of the Employment to population ratio(%) of Portugal in 1996 to that in 2002?
Provide a short and direct response. 0.91. What is the ratio of the Employment to population ratio(%) in Afghanistan in 1997 to that in 1998?
Provide a succinct answer. 1.01. What is the ratio of the Employment to population ratio(%) of Central African Republic in 1997 to that in 1998?
Offer a very short reply. 1. What is the ratio of the Employment to population ratio(%) of Cyprus in 1997 to that in 1998?
Keep it short and to the point. 1.04. What is the ratio of the Employment to population ratio(%) of Portugal in 1997 to that in 1998?
Your answer should be compact. 0.98. What is the ratio of the Employment to population ratio(%) of Afghanistan in 1997 to that in 1999?
Give a very brief answer. 1.02. What is the ratio of the Employment to population ratio(%) in Central African Republic in 1997 to that in 1999?
Provide a short and direct response. 1. What is the ratio of the Employment to population ratio(%) in Cyprus in 1997 to that in 1999?
Your response must be concise. 1.02. What is the ratio of the Employment to population ratio(%) in Portugal in 1997 to that in 1999?
Ensure brevity in your answer.  0.96. What is the ratio of the Employment to population ratio(%) in Afghanistan in 1997 to that in 2000?
Provide a short and direct response. 1.05. What is the ratio of the Employment to population ratio(%) of Cyprus in 1997 to that in 2000?
Offer a very short reply. 0.91. What is the ratio of the Employment to population ratio(%) of Portugal in 1997 to that in 2000?
Provide a succinct answer. 0.94. What is the ratio of the Employment to population ratio(%) of Afghanistan in 1997 to that in 2001?
Your response must be concise. 1.05. What is the ratio of the Employment to population ratio(%) in Central African Republic in 1997 to that in 2001?
Offer a terse response. 1. What is the ratio of the Employment to population ratio(%) in Cyprus in 1997 to that in 2001?
Your response must be concise. 0.85. What is the ratio of the Employment to population ratio(%) of Portugal in 1997 to that in 2001?
Give a very brief answer. 0.93. What is the ratio of the Employment to population ratio(%) in Afghanistan in 1997 to that in 2002?
Your answer should be compact. 1.04. What is the ratio of the Employment to population ratio(%) of Central African Republic in 1997 to that in 2002?
Make the answer very short. 1. What is the ratio of the Employment to population ratio(%) of Cyprus in 1997 to that in 2002?
Your answer should be compact. 0.82. What is the ratio of the Employment to population ratio(%) of Portugal in 1997 to that in 2002?
Give a very brief answer. 0.93. What is the ratio of the Employment to population ratio(%) in Afghanistan in 1998 to that in 1999?
Offer a terse response. 1.01. What is the ratio of the Employment to population ratio(%) of Cyprus in 1998 to that in 1999?
Provide a short and direct response. 0.99. What is the ratio of the Employment to population ratio(%) in Portugal in 1998 to that in 1999?
Your response must be concise. 0.98. What is the ratio of the Employment to population ratio(%) in Afghanistan in 1998 to that in 2000?
Provide a short and direct response. 1.04. What is the ratio of the Employment to population ratio(%) of Central African Republic in 1998 to that in 2000?
Your response must be concise. 1. What is the ratio of the Employment to population ratio(%) in Cyprus in 1998 to that in 2000?
Provide a short and direct response. 0.88. What is the ratio of the Employment to population ratio(%) in Portugal in 1998 to that in 2000?
Provide a succinct answer. 0.96. What is the ratio of the Employment to population ratio(%) of Afghanistan in 1998 to that in 2001?
Your response must be concise. 1.04. What is the ratio of the Employment to population ratio(%) of Cyprus in 1998 to that in 2001?
Provide a succinct answer. 0.82. What is the ratio of the Employment to population ratio(%) in Portugal in 1998 to that in 2001?
Your answer should be very brief. 0.95. What is the ratio of the Employment to population ratio(%) of Cyprus in 1998 to that in 2002?
Keep it short and to the point. 0.79. What is the ratio of the Employment to population ratio(%) in Portugal in 1998 to that in 2002?
Your answer should be compact. 0.95. What is the ratio of the Employment to population ratio(%) in Afghanistan in 1999 to that in 2000?
Provide a short and direct response. 1.03. What is the ratio of the Employment to population ratio(%) of Cyprus in 1999 to that in 2000?
Your response must be concise. 0.89. What is the ratio of the Employment to population ratio(%) of Portugal in 1999 to that in 2000?
Make the answer very short. 0.98. What is the ratio of the Employment to population ratio(%) in Afghanistan in 1999 to that in 2001?
Your response must be concise. 1.03. What is the ratio of the Employment to population ratio(%) in Cyprus in 1999 to that in 2001?
Give a very brief answer. 0.83. What is the ratio of the Employment to population ratio(%) in Portugal in 1999 to that in 2001?
Offer a very short reply. 0.97. What is the ratio of the Employment to population ratio(%) in Central African Republic in 1999 to that in 2002?
Provide a succinct answer. 1. What is the ratio of the Employment to population ratio(%) in Cyprus in 1999 to that in 2002?
Offer a very short reply. 0.8. What is the ratio of the Employment to population ratio(%) in Portugal in 1999 to that in 2002?
Offer a terse response. 0.97. What is the ratio of the Employment to population ratio(%) in Afghanistan in 2000 to that in 2001?
Your answer should be compact. 1. What is the ratio of the Employment to population ratio(%) of Cyprus in 2000 to that in 2001?
Offer a terse response. 0.94. What is the ratio of the Employment to population ratio(%) in Portugal in 2000 to that in 2001?
Your answer should be compact. 0.99. What is the ratio of the Employment to population ratio(%) of Afghanistan in 2000 to that in 2002?
Offer a terse response. 0.99. What is the ratio of the Employment to population ratio(%) in Cyprus in 2000 to that in 2002?
Your answer should be compact. 0.91. What is the ratio of the Employment to population ratio(%) of Portugal in 2000 to that in 2002?
Offer a terse response. 0.99. What is the ratio of the Employment to population ratio(%) of Afghanistan in 2001 to that in 2002?
Keep it short and to the point. 0.99. What is the ratio of the Employment to population ratio(%) in Cyprus in 2001 to that in 2002?
Make the answer very short. 0.97. What is the difference between the highest and the second highest Employment to population ratio(%) of Afghanistan?
Provide a succinct answer. 0.1. What is the difference between the highest and the second highest Employment to population ratio(%) in Central African Republic?
Make the answer very short. 0. What is the difference between the highest and the second highest Employment to population ratio(%) in Cyprus?
Offer a very short reply. 1.6. What is the difference between the highest and the lowest Employment to population ratio(%) in Cyprus?
Offer a terse response. 11.1. 